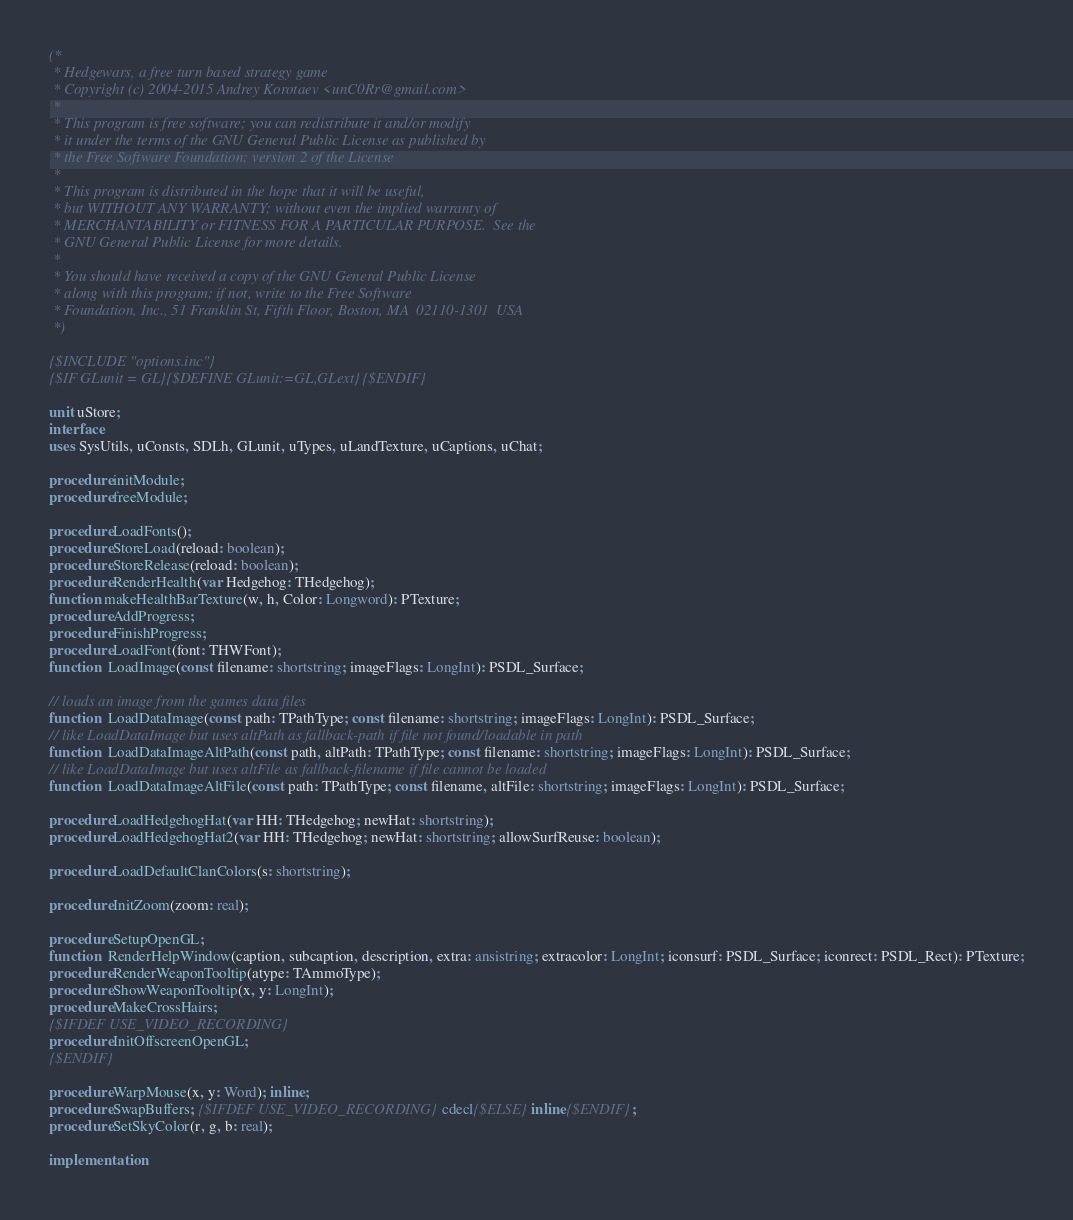Convert code to text. <code><loc_0><loc_0><loc_500><loc_500><_Pascal_>(*
 * Hedgewars, a free turn based strategy game
 * Copyright (c) 2004-2015 Andrey Korotaev <unC0Rr@gmail.com>
 *
 * This program is free software; you can redistribute it and/or modify
 * it under the terms of the GNU General Public License as published by
 * the Free Software Foundation; version 2 of the License
 *
 * This program is distributed in the hope that it will be useful,
 * but WITHOUT ANY WARRANTY; without even the implied warranty of
 * MERCHANTABILITY or FITNESS FOR A PARTICULAR PURPOSE.  See the
 * GNU General Public License for more details.
 *
 * You should have received a copy of the GNU General Public License
 * along with this program; if not, write to the Free Software
 * Foundation, Inc., 51 Franklin St, Fifth Floor, Boston, MA  02110-1301  USA
 *)

{$INCLUDE "options.inc"}
{$IF GLunit = GL}{$DEFINE GLunit:=GL,GLext}{$ENDIF}

unit uStore;
interface
uses SysUtils, uConsts, SDLh, GLunit, uTypes, uLandTexture, uCaptions, uChat;

procedure initModule;
procedure freeModule;

procedure LoadFonts();
procedure StoreLoad(reload: boolean);
procedure StoreRelease(reload: boolean);
procedure RenderHealth(var Hedgehog: THedgehog);
function makeHealthBarTexture(w, h, Color: Longword): PTexture;
procedure AddProgress;
procedure FinishProgress;
procedure LoadFont(font: THWFont);
function  LoadImage(const filename: shortstring; imageFlags: LongInt): PSDL_Surface;

// loads an image from the games data files
function  LoadDataImage(const path: TPathType; const filename: shortstring; imageFlags: LongInt): PSDL_Surface;
// like LoadDataImage but uses altPath as fallback-path if file not found/loadable in path
function  LoadDataImageAltPath(const path, altPath: TPathType; const filename: shortstring; imageFlags: LongInt): PSDL_Surface;
// like LoadDataImage but uses altFile as fallback-filename if file cannot be loaded
function  LoadDataImageAltFile(const path: TPathType; const filename, altFile: shortstring; imageFlags: LongInt): PSDL_Surface;

procedure LoadHedgehogHat(var HH: THedgehog; newHat: shortstring);
procedure LoadHedgehogHat2(var HH: THedgehog; newHat: shortstring; allowSurfReuse: boolean);

procedure LoadDefaultClanColors(s: shortstring);

procedure InitZoom(zoom: real);

procedure SetupOpenGL;
function  RenderHelpWindow(caption, subcaption, description, extra: ansistring; extracolor: LongInt; iconsurf: PSDL_Surface; iconrect: PSDL_Rect): PTexture;
procedure RenderWeaponTooltip(atype: TAmmoType);
procedure ShowWeaponTooltip(x, y: LongInt);
procedure MakeCrossHairs;
{$IFDEF USE_VIDEO_RECORDING}
procedure InitOffscreenOpenGL;
{$ENDIF}

procedure WarpMouse(x, y: Word); inline;
procedure SwapBuffers; {$IFDEF USE_VIDEO_RECORDING}cdecl{$ELSE}inline{$ENDIF};
procedure SetSkyColor(r, g, b: real);

implementation</code> 